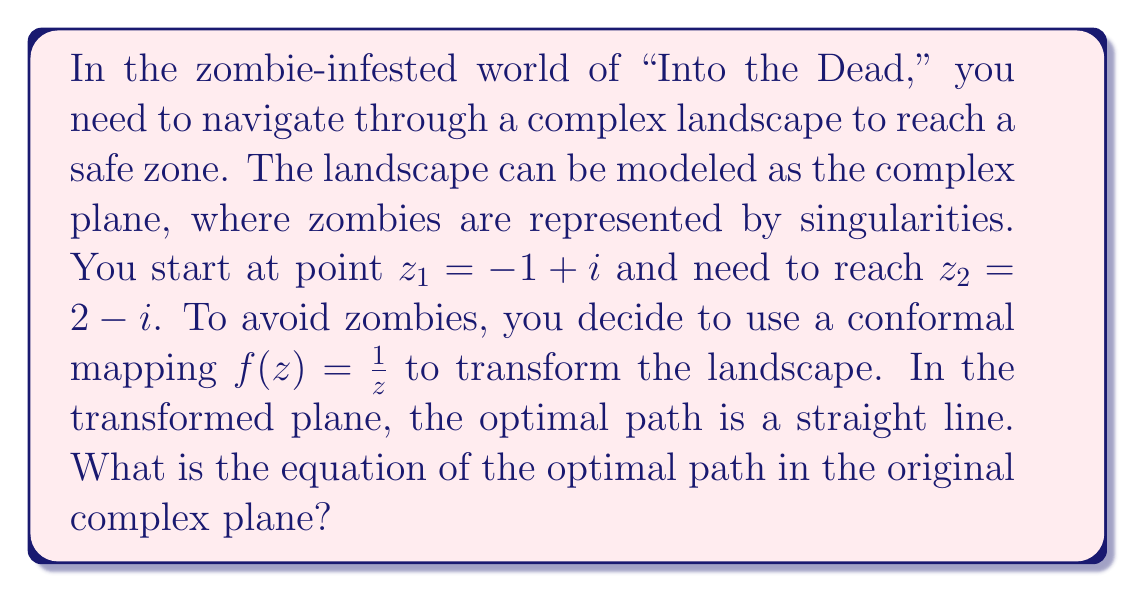What is the answer to this math problem? Let's approach this step-by-step:

1) First, we need to find the images of $z_1$ and $z_2$ under the conformal mapping $f(z) = \frac{1}{z}$.

   For $z_1 = -1 + i$:
   $$f(z_1) = \frac{1}{-1+i} = \frac{-1-i}{(-1)^2 + 1^2} = \frac{-1-i}{2}$$

   For $z_2 = 2 - i$:
   $$f(z_2) = \frac{1}{2-i} = \frac{2+i}{2^2 + (-1)^2} = \frac{2+i}{5}$$

2) In the transformed plane, the optimal path is a straight line between these two points. The equation of this line is:

   $$w = \frac{-1-i}{2} + t(\frac{2+i}{5} - \frac{-1-i}{2}),\quad 0 \leq t \leq 1$$

3) To find the equation in the original plane, we need to apply the inverse transformation $z = \frac{1}{w}$:

   $$z = \frac{1}{\frac{-1-i}{2} + t(\frac{2+i}{5} - \frac{-1-i}{2})}$$

4) Simplifying the denominator:

   $$z = \frac{1}{\frac{-1-i}{2} + t(\frac{4+2i}{10} + \frac{1+i}{2})} = \frac{1}{\frac{-1-i}{2} + t(\frac{9+3i}{10})}$$

5) This can be written as:

   $$z = \frac{1}{\frac{-5-5i+9t+3ti}{10}} = \frac{10}{-5-5i+9t+3ti}$$

This is the equation of the optimal path in the original complex plane.
Answer: The equation of the optimal path in the original complex plane is:

$$z = \frac{10}{-5-5i+9t+3ti},\quad 0 \leq t \leq 1$$ 